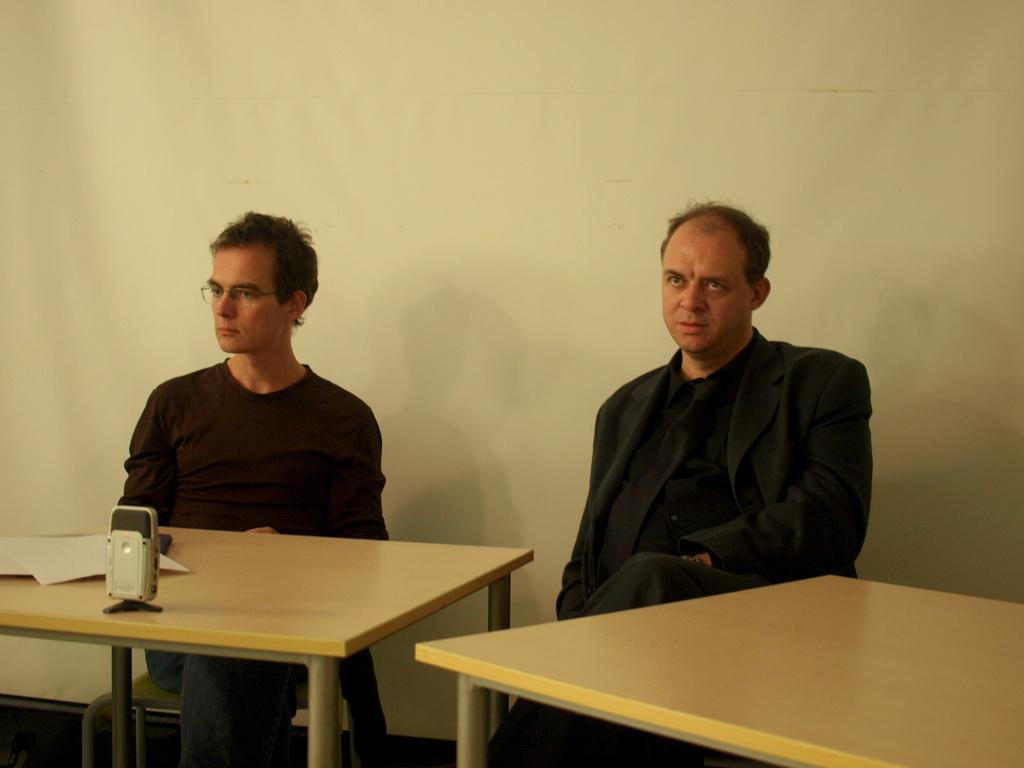How many people are in the image? There are two people in the image. What are the people doing in the image? The people are sitting on chairs. What object can be seen on the table in the image? There is a voice recorder on the table. What might the people be using the voice recorder for? The people might be using the voice recorder for recording audio or interviews. How many crows are perched on the table in the image? There are no crows present in the image; it only features two people sitting on chairs and a voice recorder on the table. 